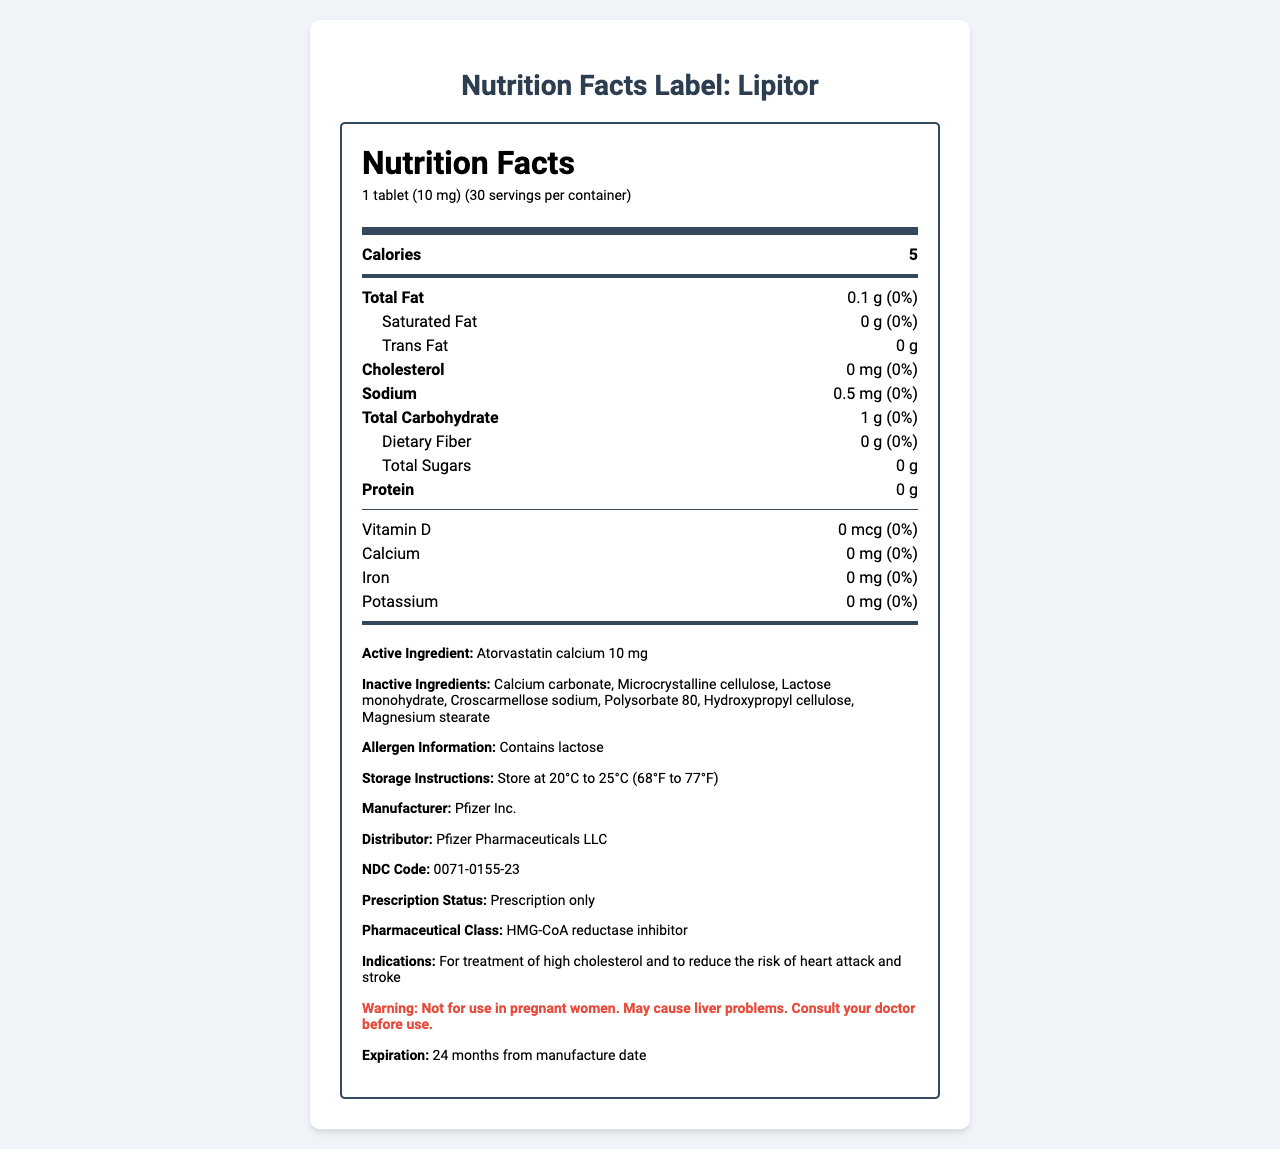what is the serving size of Lipitor? The serving size is stated as "1 tablet (10 mg)" in the document.
Answer: 1 tablet (10 mg) how many calories are in a serving of Lipitor? The document lists the number of calories per serving as 5.
Answer: 5 what is the total amount of fat in one serving of Lipitor? The total fat content is given as "0.1 g" per serving.
Answer: 0.1 g how much cholesterol is in one serving of Lipitor? The cholesterol content per serving is "0 mg" as specified in the document.
Answer: 0 mg what are the inactive ingredients in Lipitor? The inactive ingredients are listed under the section "Inactive Ingredients."
Answer: Calcium carbonate, Microcrystalline cellulose, Lactose monohydrate, Croscarmellose sodium, Polysorbate 80, Hydroxypropyl cellulose, Magnesium stearate which vitamin is listed in the Nutrition Facts Label for Lipitor and what is its amount per serving? A. Vitamin A B. Vitamin C C. Vitamin D D. Vitamin B12 The document mentions Vitamin D with an amount of 0 mcg per serving.
Answer: C. Vitamin D what is the daily value percentage of sodium in one serving of Lipitor? A. 1% B. 5% C. 0% D. 2% The daily value percentage of sodium is listed as "0%" in the document.
Answer: C. 0% is Lipitor prescription only? The document states "Prescription only" under the prescription status.
Answer: Yes does Lipitor contain lactose? The allergen information section explicitly states "Contains lactose."
Answer: Yes summarize the document. The summary includes major sections such as nutrition facts, ingredients, usage indications, and warnings.
Answer: The document is a Nutrition Facts Label for Lipitor, a prescription medication used to treat high cholesterol. The label details the serving size, calories, macronutrients, vitamins, and minerals per serving. It also lists active and inactive ingredients, allergen information, storage instructions, manufacturer and distributor details, NDC code, pharmaceutical class, indications, and a warning note. what is the expiration date for Lipitor mentioned in the document? The expiration date is specified as "24 months from manufacture date" in the document.
Answer: 24 months from manufacture date is there any dietary fiber in one serving of Lipitor? The document mentions the dietary fiber content as "0 g" per serving.
Answer: No what is the amount of the active ingredient in a single tablet of Lipitor? The active ingredient Atorvastatin calcium is listed as "10 mg" per tablet.
Answer: 10 mg what is the storage instruction for Lipitor? The storage instructions specify to keep the product at "20°C to 25°C (68°F to 77°F)."
Answer: Store at 20°C to 25°C (68°F to 77°F) why is Lipitor used? The indications section states it is used for treating high cholesterol and reducing the risk of heart attack and stroke.
Answer: To treat high cholesterol and reduce the risk of heart attack and stroke what is the trans fat content in one serving of Lipitor? The trans fat content is listed as "0 g" per serving.
Answer: 0 g what is the manufacturer of Lipitor? The manufacturer is listed under the section "Manufacturer."
Answer: Pfizer Inc. can you determine what the monthly cost of Lipitor is from this document? The document only provides nutritional and ingredient information, along with usage indications and warnings. There is no pricing information included.
Answer: Cannot be determined 